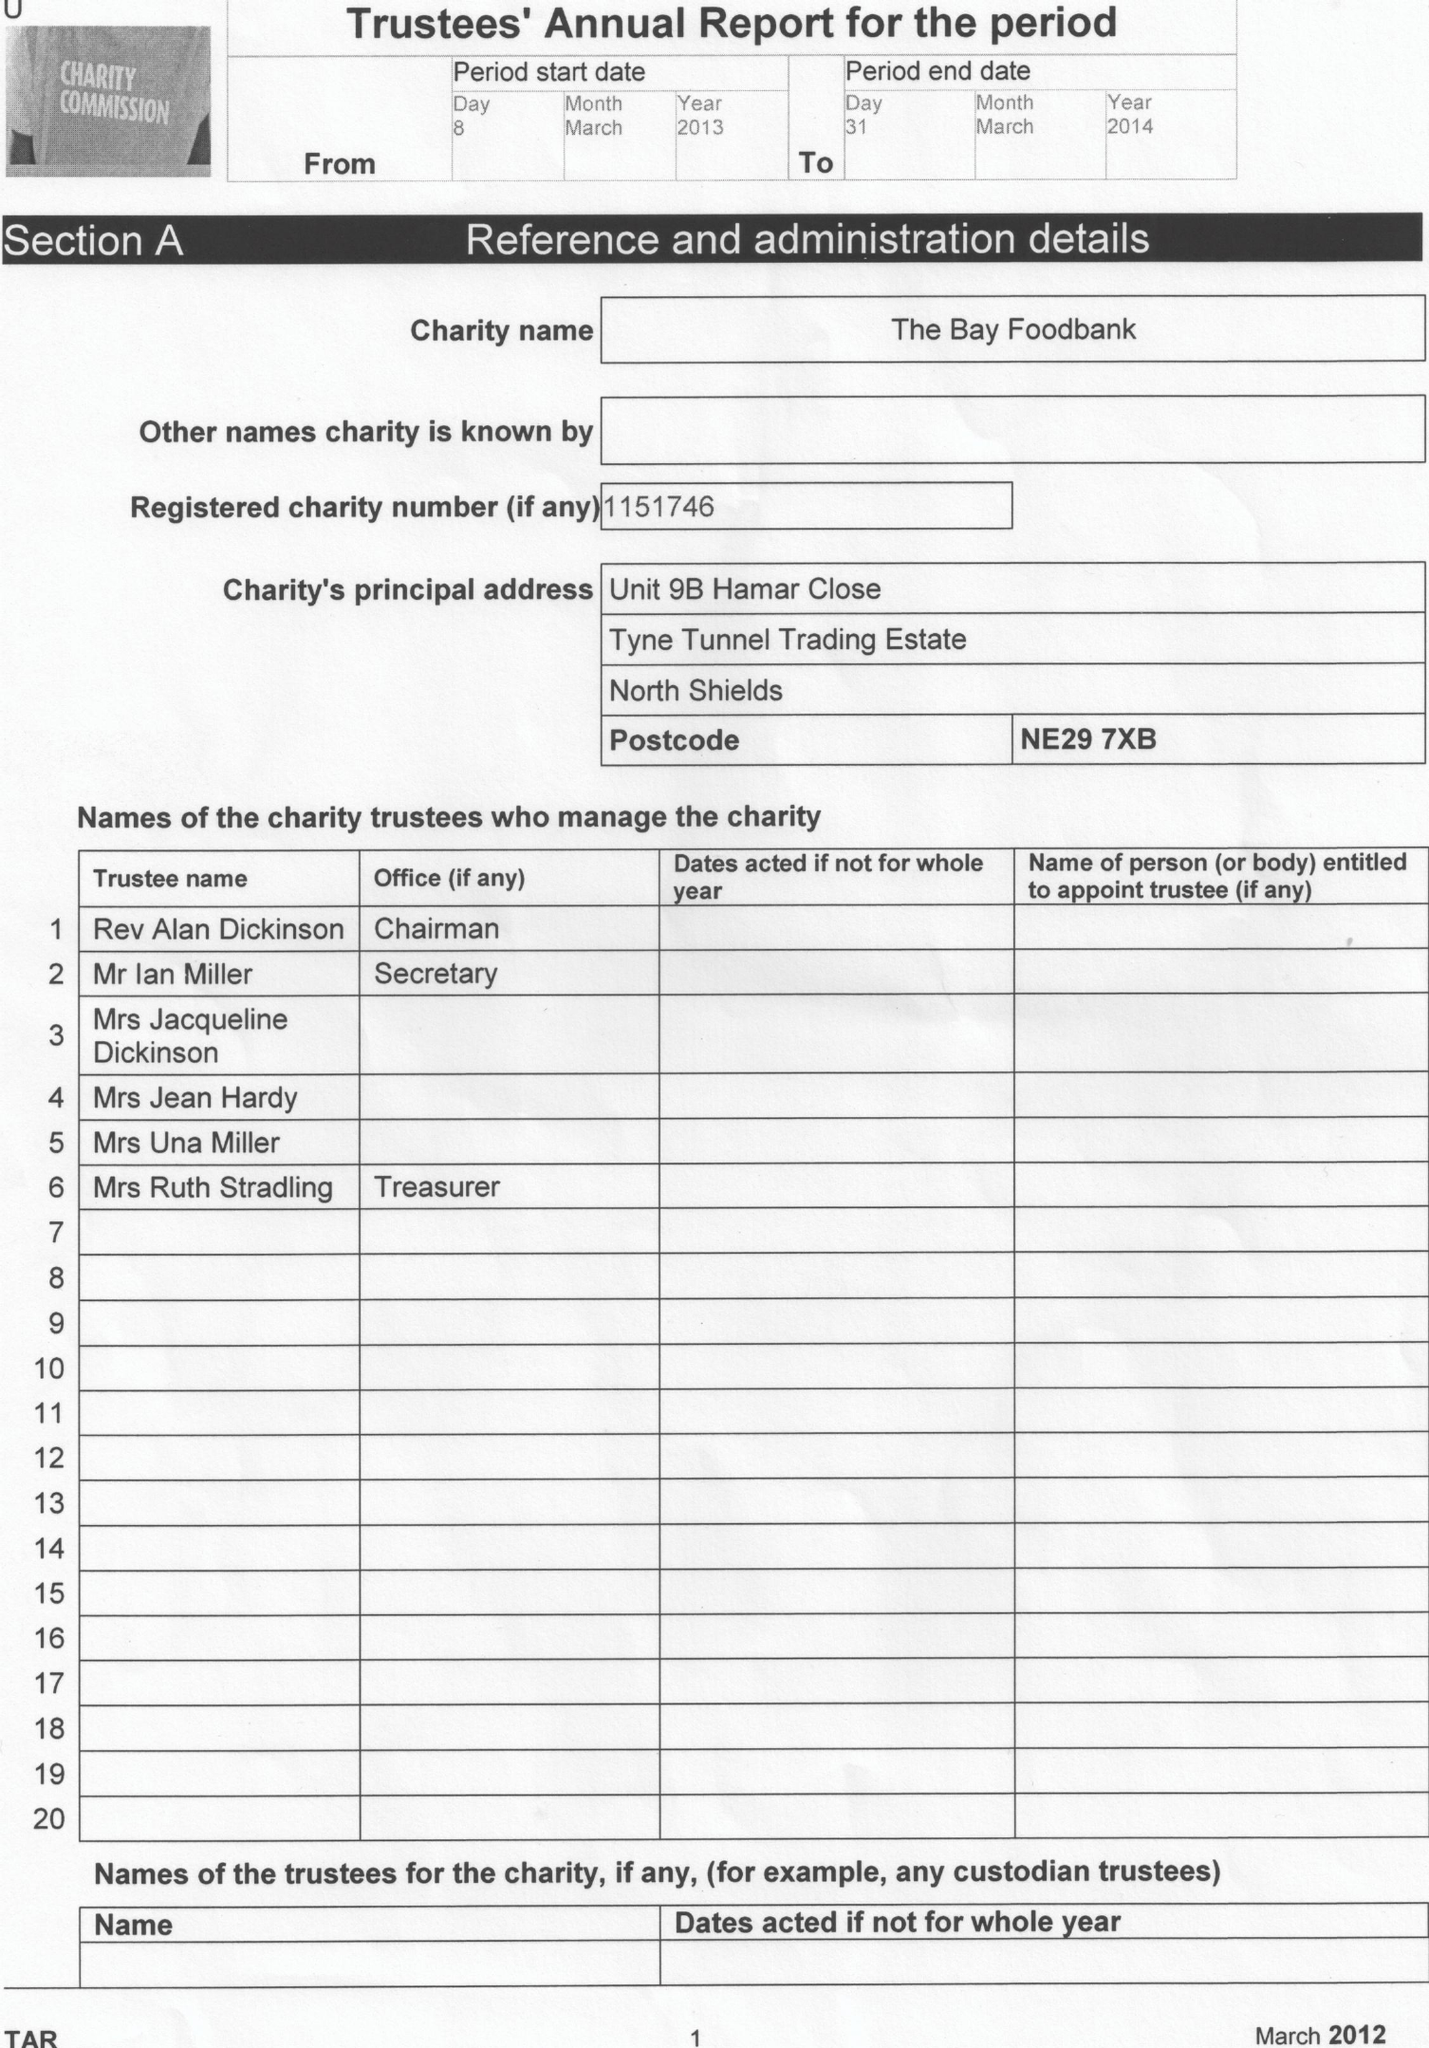What is the value for the report_date?
Answer the question using a single word or phrase. 2014-03-31 